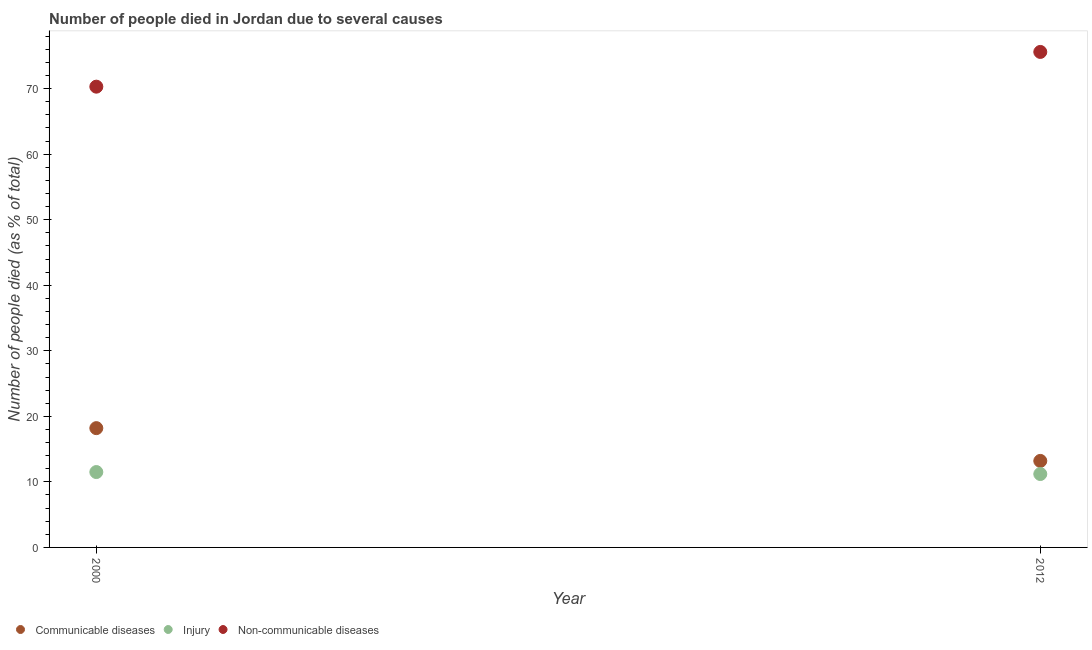Is the number of dotlines equal to the number of legend labels?
Provide a short and direct response. Yes. What is the number of people who dies of non-communicable diseases in 2012?
Ensure brevity in your answer.  75.6. Across all years, what is the minimum number of people who died of communicable diseases?
Your response must be concise. 13.2. In which year was the number of people who died of injury maximum?
Offer a terse response. 2000. In which year was the number of people who died of injury minimum?
Offer a terse response. 2012. What is the total number of people who died of communicable diseases in the graph?
Offer a very short reply. 31.4. What is the difference between the number of people who died of injury in 2000 and that in 2012?
Your response must be concise. 0.3. What is the difference between the number of people who died of communicable diseases in 2012 and the number of people who died of injury in 2000?
Make the answer very short. 1.7. What is the average number of people who died of injury per year?
Keep it short and to the point. 11.35. In the year 2000, what is the difference between the number of people who dies of non-communicable diseases and number of people who died of communicable diseases?
Make the answer very short. 52.1. In how many years, is the number of people who dies of non-communicable diseases greater than 46 %?
Your answer should be compact. 2. What is the ratio of the number of people who dies of non-communicable diseases in 2000 to that in 2012?
Your response must be concise. 0.93. Is the number of people who dies of non-communicable diseases in 2000 less than that in 2012?
Ensure brevity in your answer.  Yes. Is the number of people who dies of non-communicable diseases strictly greater than the number of people who died of communicable diseases over the years?
Make the answer very short. Yes. Is the number of people who died of communicable diseases strictly less than the number of people who dies of non-communicable diseases over the years?
Offer a very short reply. Yes. How many years are there in the graph?
Your answer should be very brief. 2. What is the difference between two consecutive major ticks on the Y-axis?
Your response must be concise. 10. How many legend labels are there?
Ensure brevity in your answer.  3. How are the legend labels stacked?
Your answer should be very brief. Horizontal. What is the title of the graph?
Give a very brief answer. Number of people died in Jordan due to several causes. What is the label or title of the Y-axis?
Offer a very short reply. Number of people died (as % of total). What is the Number of people died (as % of total) of Injury in 2000?
Keep it short and to the point. 11.5. What is the Number of people died (as % of total) in Non-communicable diseases in 2000?
Your answer should be compact. 70.3. What is the Number of people died (as % of total) of Injury in 2012?
Provide a succinct answer. 11.2. What is the Number of people died (as % of total) in Non-communicable diseases in 2012?
Your response must be concise. 75.6. Across all years, what is the maximum Number of people died (as % of total) of Non-communicable diseases?
Provide a succinct answer. 75.6. Across all years, what is the minimum Number of people died (as % of total) of Communicable diseases?
Provide a short and direct response. 13.2. Across all years, what is the minimum Number of people died (as % of total) of Injury?
Your answer should be very brief. 11.2. Across all years, what is the minimum Number of people died (as % of total) of Non-communicable diseases?
Ensure brevity in your answer.  70.3. What is the total Number of people died (as % of total) of Communicable diseases in the graph?
Ensure brevity in your answer.  31.4. What is the total Number of people died (as % of total) of Injury in the graph?
Give a very brief answer. 22.7. What is the total Number of people died (as % of total) of Non-communicable diseases in the graph?
Your response must be concise. 145.9. What is the difference between the Number of people died (as % of total) in Communicable diseases in 2000 and that in 2012?
Keep it short and to the point. 5. What is the difference between the Number of people died (as % of total) of Injury in 2000 and that in 2012?
Ensure brevity in your answer.  0.3. What is the difference between the Number of people died (as % of total) of Non-communicable diseases in 2000 and that in 2012?
Your answer should be very brief. -5.3. What is the difference between the Number of people died (as % of total) of Communicable diseases in 2000 and the Number of people died (as % of total) of Non-communicable diseases in 2012?
Ensure brevity in your answer.  -57.4. What is the difference between the Number of people died (as % of total) of Injury in 2000 and the Number of people died (as % of total) of Non-communicable diseases in 2012?
Keep it short and to the point. -64.1. What is the average Number of people died (as % of total) in Communicable diseases per year?
Give a very brief answer. 15.7. What is the average Number of people died (as % of total) of Injury per year?
Keep it short and to the point. 11.35. What is the average Number of people died (as % of total) of Non-communicable diseases per year?
Keep it short and to the point. 72.95. In the year 2000, what is the difference between the Number of people died (as % of total) in Communicable diseases and Number of people died (as % of total) in Injury?
Offer a very short reply. 6.7. In the year 2000, what is the difference between the Number of people died (as % of total) of Communicable diseases and Number of people died (as % of total) of Non-communicable diseases?
Your answer should be compact. -52.1. In the year 2000, what is the difference between the Number of people died (as % of total) of Injury and Number of people died (as % of total) of Non-communicable diseases?
Give a very brief answer. -58.8. In the year 2012, what is the difference between the Number of people died (as % of total) of Communicable diseases and Number of people died (as % of total) of Non-communicable diseases?
Your answer should be very brief. -62.4. In the year 2012, what is the difference between the Number of people died (as % of total) in Injury and Number of people died (as % of total) in Non-communicable diseases?
Give a very brief answer. -64.4. What is the ratio of the Number of people died (as % of total) in Communicable diseases in 2000 to that in 2012?
Provide a short and direct response. 1.38. What is the ratio of the Number of people died (as % of total) of Injury in 2000 to that in 2012?
Ensure brevity in your answer.  1.03. What is the ratio of the Number of people died (as % of total) of Non-communicable diseases in 2000 to that in 2012?
Provide a succinct answer. 0.93. What is the difference between the highest and the second highest Number of people died (as % of total) in Injury?
Give a very brief answer. 0.3. What is the difference between the highest and the lowest Number of people died (as % of total) of Communicable diseases?
Your response must be concise. 5. What is the difference between the highest and the lowest Number of people died (as % of total) in Injury?
Give a very brief answer. 0.3. 